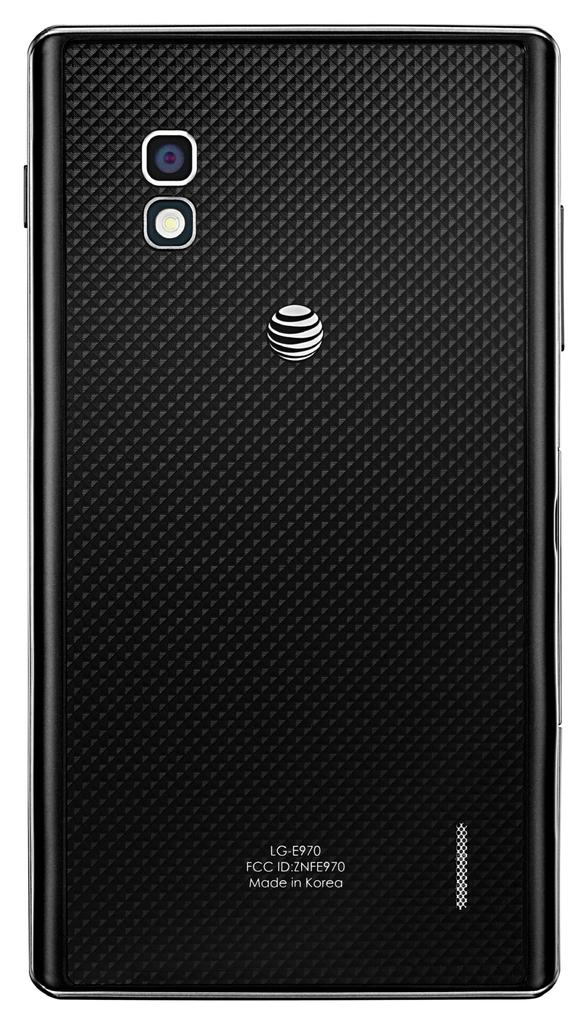What is the main subject of the image? The main subject of the image is the backside view of a mobile. What specific feature can be seen on the mobile? There is a camera lens visible on the mobile. Are there any branding elements on the mobile? Yes, there is a logo on the mobile. What else is present on the mobile besides the logo? There is text on the mobile. What color is the background of the image? The background of the image is white. Can you see a boy kissing the mobile in the image? No, there is no boy or any kissing action present in the image. What type of government is depicted on the mobile in the image? There is no government depicted on the mobile; it only features a logo, text, and a camera lens. 